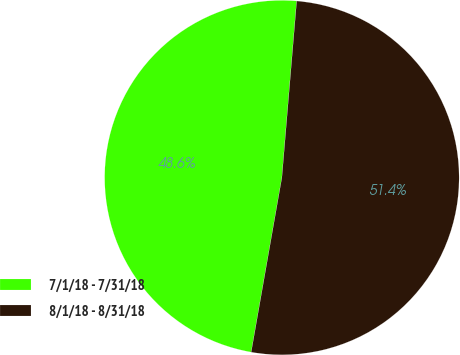Convert chart to OTSL. <chart><loc_0><loc_0><loc_500><loc_500><pie_chart><fcel>7/1/18 - 7/31/18<fcel>8/1/18 - 8/31/18<nl><fcel>48.56%<fcel>51.44%<nl></chart> 